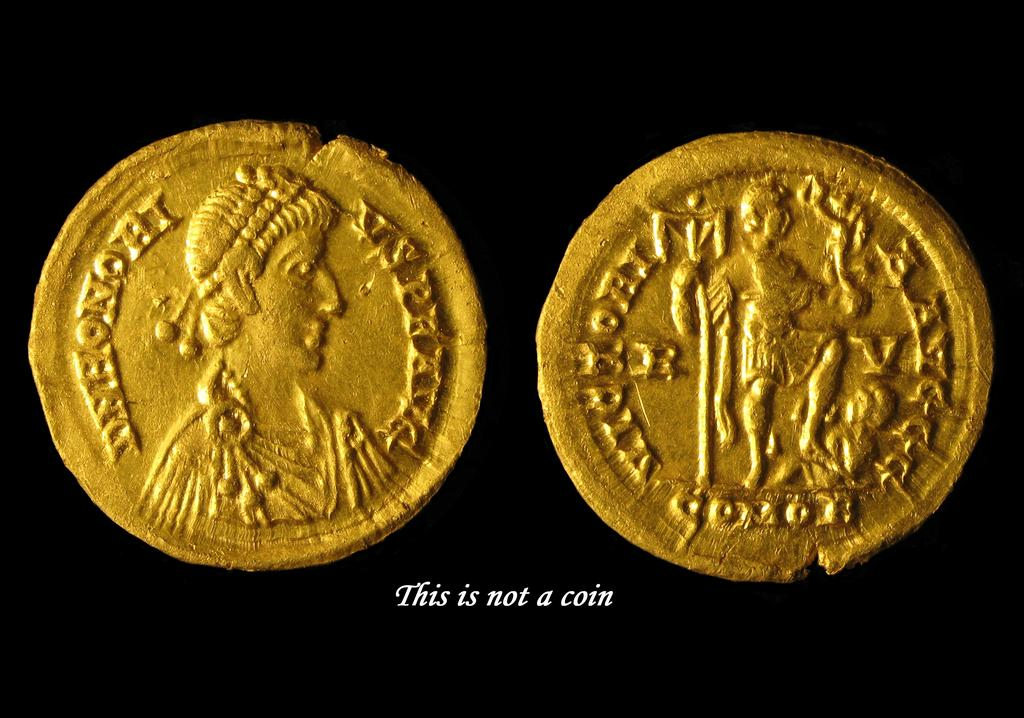<image>
Write a terse but informative summary of the picture. A photograph of two gold pieces has text which reads "this is not a coin" 